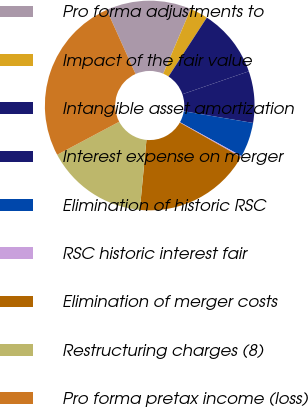<chart> <loc_0><loc_0><loc_500><loc_500><pie_chart><fcel>Pro forma adjustments to<fcel>Impact of the fair value<fcel>Intangible asset amortization<fcel>Interest expense on merger<fcel>Elimination of historic RSC<fcel>RSC historic interest fair<fcel>Elimination of merger costs<fcel>Restructuring charges (8)<fcel>Pro forma pretax income (loss)<nl><fcel>13.12%<fcel>2.78%<fcel>10.54%<fcel>7.95%<fcel>5.36%<fcel>0.19%<fcel>18.3%<fcel>15.71%<fcel>26.06%<nl></chart> 